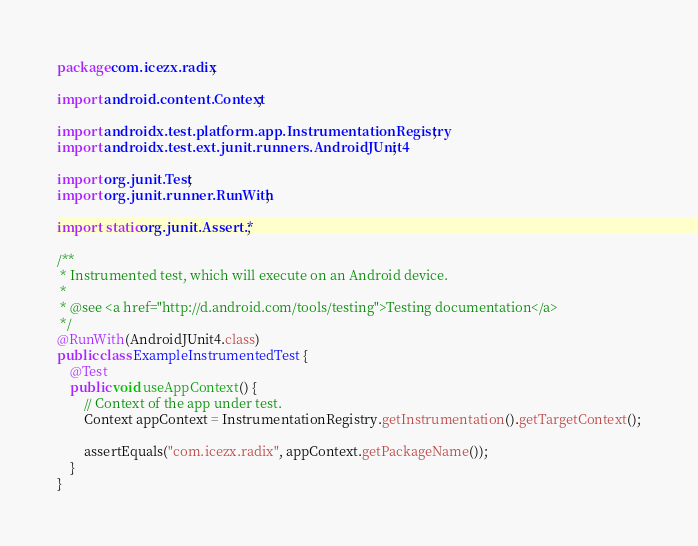<code> <loc_0><loc_0><loc_500><loc_500><_Java_>package com.icezx.radix;

import android.content.Context;

import androidx.test.platform.app.InstrumentationRegistry;
import androidx.test.ext.junit.runners.AndroidJUnit4;

import org.junit.Test;
import org.junit.runner.RunWith;

import static org.junit.Assert.*;

/**
 * Instrumented test, which will execute on an Android device.
 *
 * @see <a href="http://d.android.com/tools/testing">Testing documentation</a>
 */
@RunWith(AndroidJUnit4.class)
public class ExampleInstrumentedTest {
    @Test
    public void useAppContext() {
        // Context of the app under test.
        Context appContext = InstrumentationRegistry.getInstrumentation().getTargetContext();

        assertEquals("com.icezx.radix", appContext.getPackageName());
    }
}
</code> 